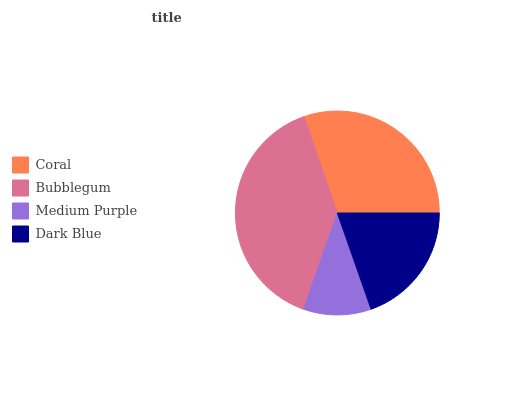Is Medium Purple the minimum?
Answer yes or no. Yes. Is Bubblegum the maximum?
Answer yes or no. Yes. Is Bubblegum the minimum?
Answer yes or no. No. Is Medium Purple the maximum?
Answer yes or no. No. Is Bubblegum greater than Medium Purple?
Answer yes or no. Yes. Is Medium Purple less than Bubblegum?
Answer yes or no. Yes. Is Medium Purple greater than Bubblegum?
Answer yes or no. No. Is Bubblegum less than Medium Purple?
Answer yes or no. No. Is Coral the high median?
Answer yes or no. Yes. Is Dark Blue the low median?
Answer yes or no. Yes. Is Bubblegum the high median?
Answer yes or no. No. Is Medium Purple the low median?
Answer yes or no. No. 